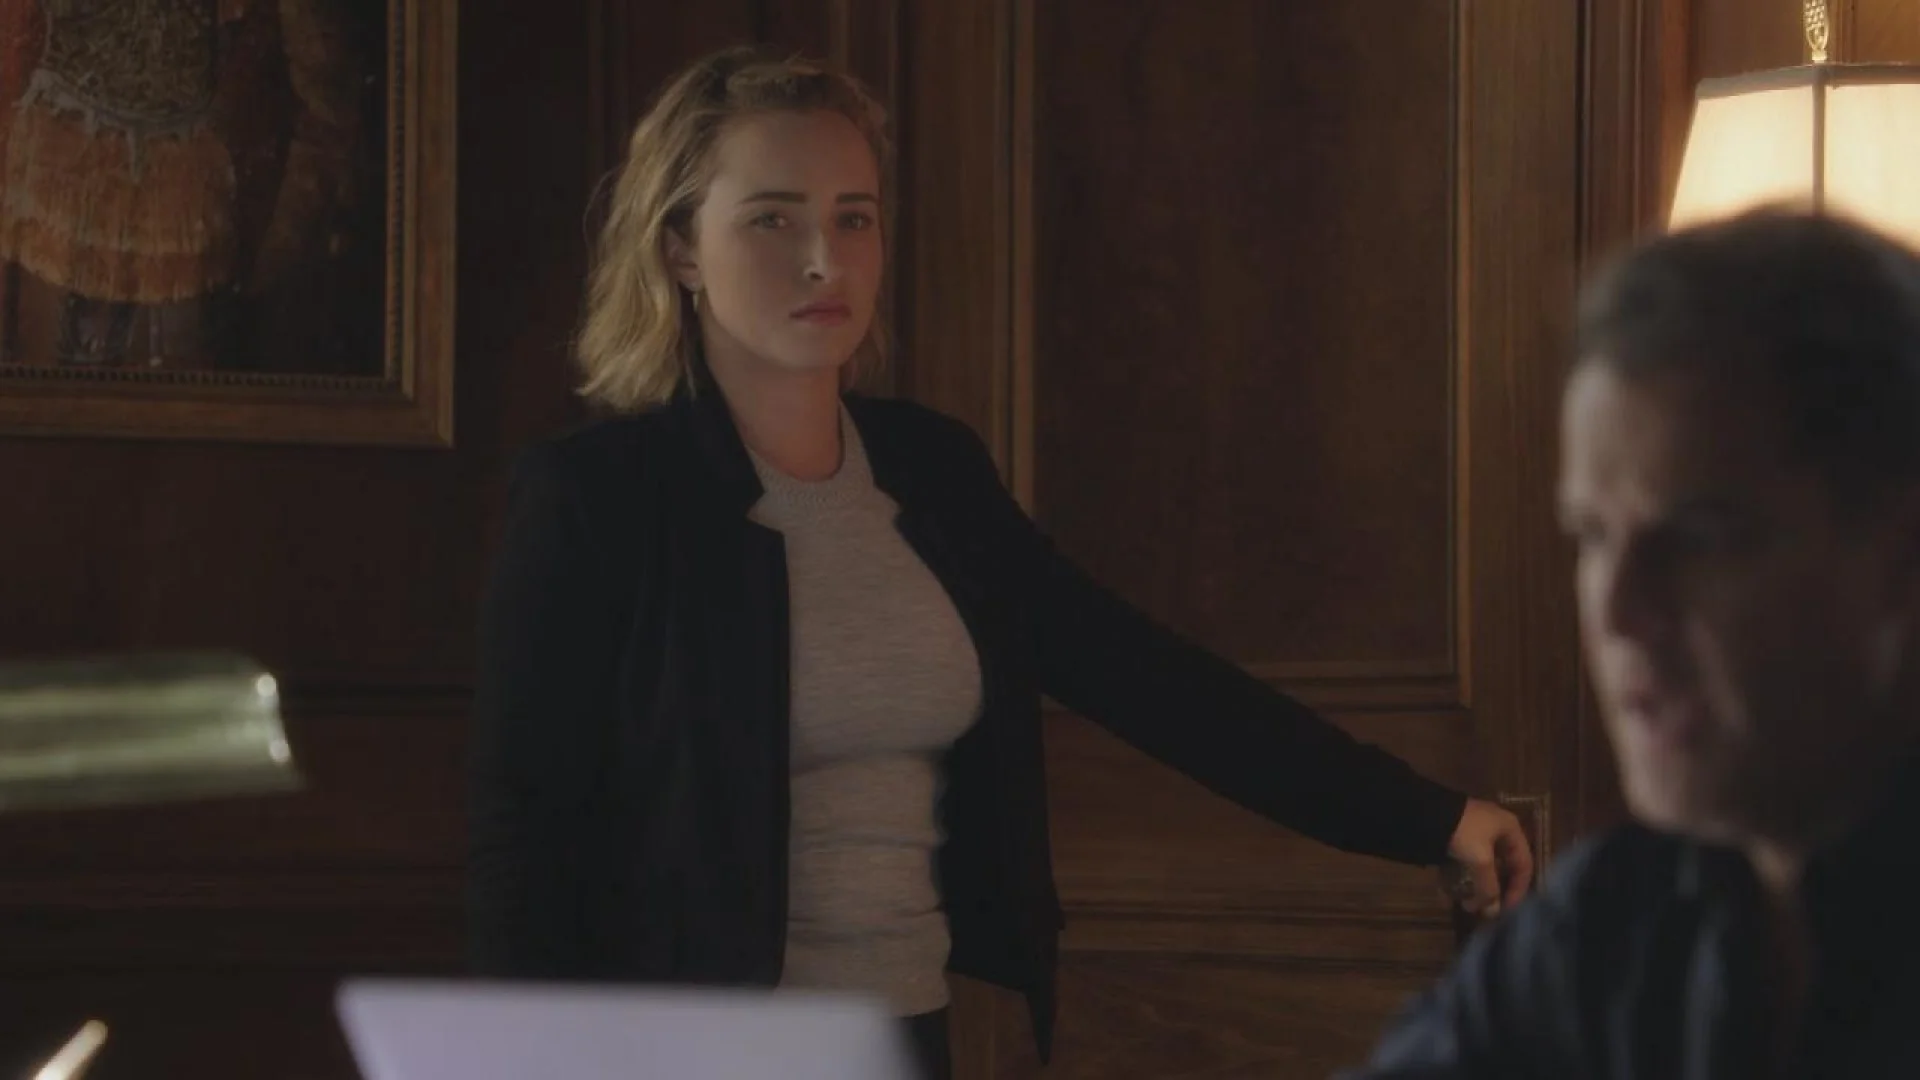Can you describe any emotional undertones in the woman's expression? The woman's expression conveys a blend of determination and concern. Her furrowed brows and intense gaze indicate that she is deeply engaged and possibly troubled by the subject matter of their conversation. Her posture and facial expression suggest that the interaction is of significant personal or professional importance. 